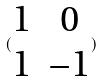<formula> <loc_0><loc_0><loc_500><loc_500>( \begin{matrix} 1 & 0 \\ 1 & - 1 \end{matrix} )</formula> 